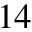Convert formula to latex. <formula><loc_0><loc_0><loc_500><loc_500>_ { 1 4 }</formula> 